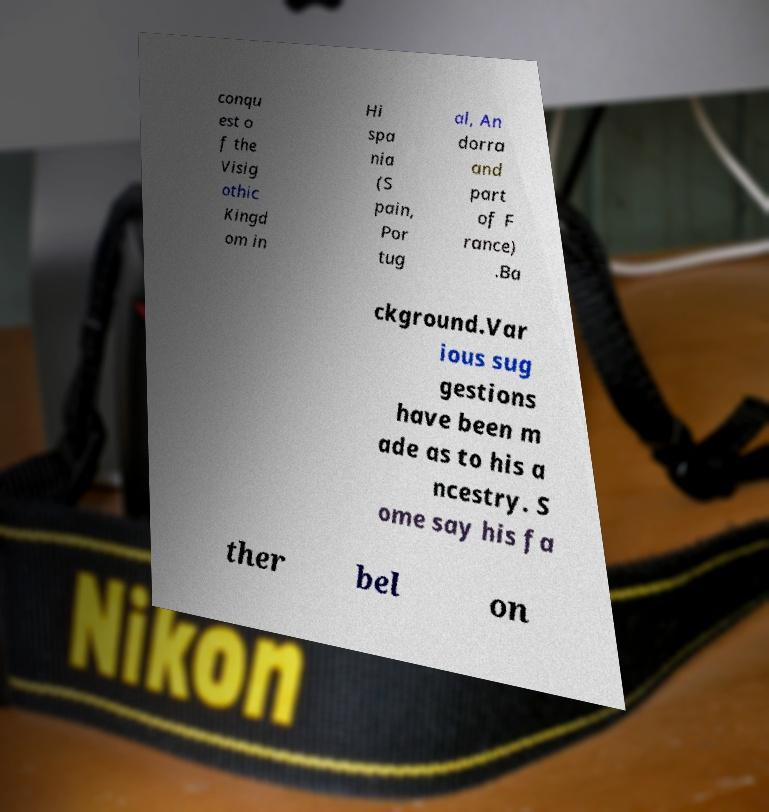Can you accurately transcribe the text from the provided image for me? conqu est o f the Visig othic Kingd om in Hi spa nia (S pain, Por tug al, An dorra and part of F rance) .Ba ckground.Var ious sug gestions have been m ade as to his a ncestry. S ome say his fa ther bel on 